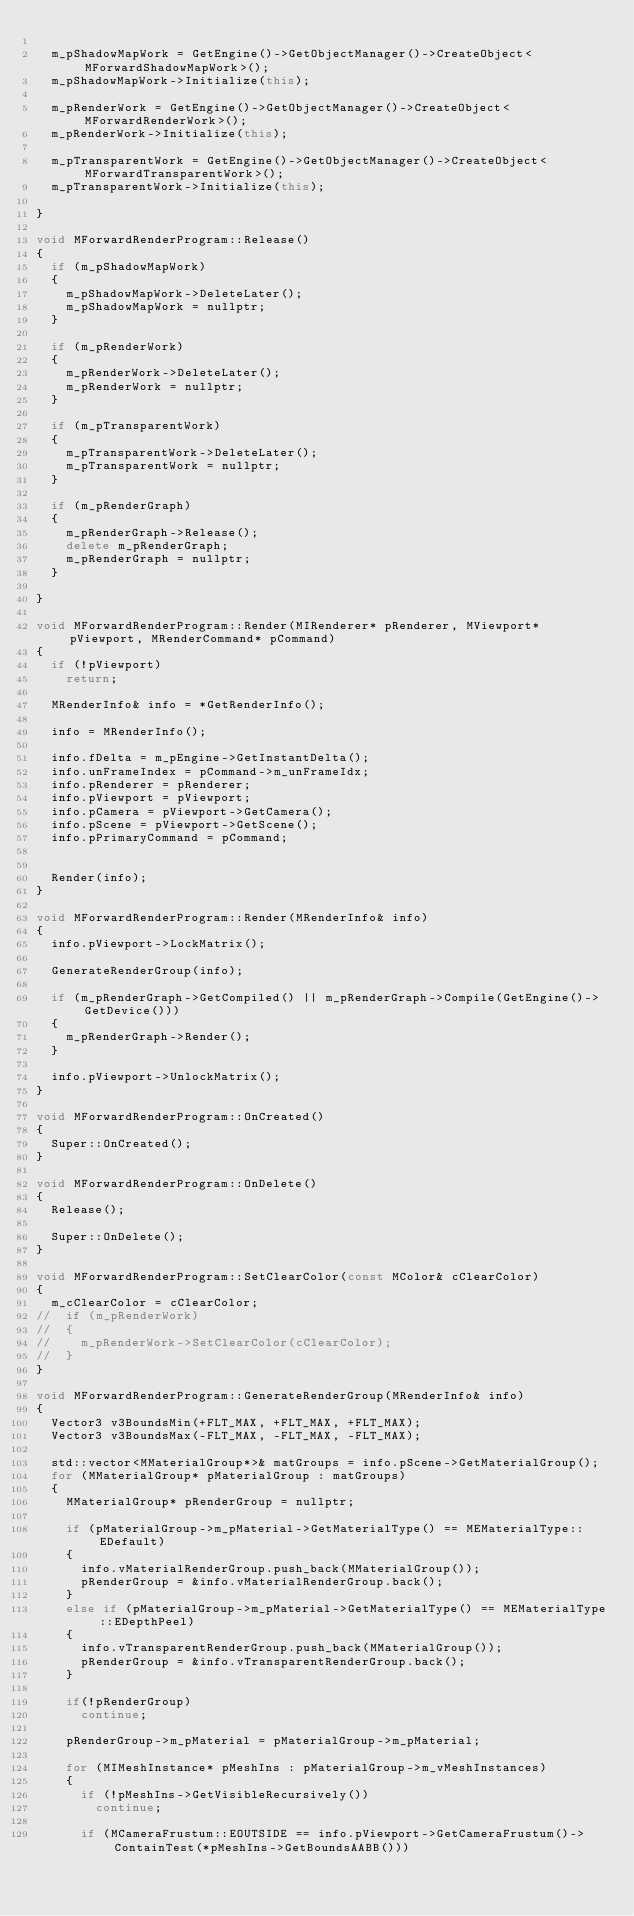<code> <loc_0><loc_0><loc_500><loc_500><_C++_>
	m_pShadowMapWork = GetEngine()->GetObjectManager()->CreateObject<MForwardShadowMapWork>();
	m_pShadowMapWork->Initialize(this);

	m_pRenderWork = GetEngine()->GetObjectManager()->CreateObject<MForwardRenderWork>();
	m_pRenderWork->Initialize(this);

	m_pTransparentWork = GetEngine()->GetObjectManager()->CreateObject<MForwardTransparentWork>();
	m_pTransparentWork->Initialize(this);

}

void MForwardRenderProgram::Release()
{
	if (m_pShadowMapWork)
	{
		m_pShadowMapWork->DeleteLater();
		m_pShadowMapWork = nullptr;
	}

	if (m_pRenderWork)
	{
		m_pRenderWork->DeleteLater();
		m_pRenderWork = nullptr;
	}

	if (m_pTransparentWork)
	{
		m_pTransparentWork->DeleteLater();
		m_pTransparentWork = nullptr;
	}

	if (m_pRenderGraph)
	{
		m_pRenderGraph->Release();
		delete m_pRenderGraph;
		m_pRenderGraph = nullptr;
	}

}

void MForwardRenderProgram::Render(MIRenderer* pRenderer, MViewport* pViewport, MRenderCommand* pCommand)
{
	if (!pViewport)
		return;

	MRenderInfo& info = *GetRenderInfo();

	info = MRenderInfo();

	info.fDelta = m_pEngine->GetInstantDelta();
	info.unFrameIndex = pCommand->m_unFrameIdx;
	info.pRenderer = pRenderer;
	info.pViewport = pViewport;
	info.pCamera = pViewport->GetCamera();
	info.pScene = pViewport->GetScene();
	info.pPrimaryCommand = pCommand;


	Render(info);
}

void MForwardRenderProgram::Render(MRenderInfo& info)
{
	info.pViewport->LockMatrix();

	GenerateRenderGroup(info);
	
	if (m_pRenderGraph->GetCompiled() || m_pRenderGraph->Compile(GetEngine()->GetDevice()))
	{
		m_pRenderGraph->Render();
	}

	info.pViewport->UnlockMatrix();
}

void MForwardRenderProgram::OnCreated()
{
	Super::OnCreated();
}

void MForwardRenderProgram::OnDelete()
{
	Release();

	Super::OnDelete();
}

void MForwardRenderProgram::SetClearColor(const MColor& cClearColor)
{
	m_cClearColor = cClearColor;
// 	if (m_pRenderWork)
// 	{
// 		m_pRenderWork->SetClearColor(cClearColor);
// 	}
}

void MForwardRenderProgram::GenerateRenderGroup(MRenderInfo& info)
{
	Vector3 v3BoundsMin(+FLT_MAX, +FLT_MAX, +FLT_MAX);
	Vector3 v3BoundsMax(-FLT_MAX, -FLT_MAX, -FLT_MAX);

	std::vector<MMaterialGroup*>& matGroups = info.pScene->GetMaterialGroup();
	for (MMaterialGroup* pMaterialGroup : matGroups)
	{
		MMaterialGroup* pRenderGroup = nullptr;

		if (pMaterialGroup->m_pMaterial->GetMaterialType() == MEMaterialType::EDefault)
		{
			info.vMaterialRenderGroup.push_back(MMaterialGroup());
			pRenderGroup = &info.vMaterialRenderGroup.back();
		}
		else if (pMaterialGroup->m_pMaterial->GetMaterialType() == MEMaterialType::EDepthPeel)
		{
			info.vTransparentRenderGroup.push_back(MMaterialGroup());
			pRenderGroup = &info.vTransparentRenderGroup.back();
		}

		if(!pRenderGroup)
			continue;

		pRenderGroup->m_pMaterial = pMaterialGroup->m_pMaterial;

		for (MIMeshInstance* pMeshIns : pMaterialGroup->m_vMeshInstances)
		{
			if (!pMeshIns->GetVisibleRecursively())
				continue;

			if (MCameraFrustum::EOUTSIDE == info.pViewport->GetCameraFrustum()->ContainTest(*pMeshIns->GetBoundsAABB()))</code> 